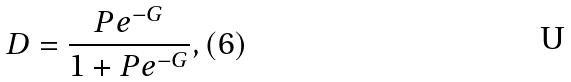Convert formula to latex. <formula><loc_0><loc_0><loc_500><loc_500>D = \frac { P e ^ { - G } } { 1 + P e ^ { - G } } , ( 6 )</formula> 